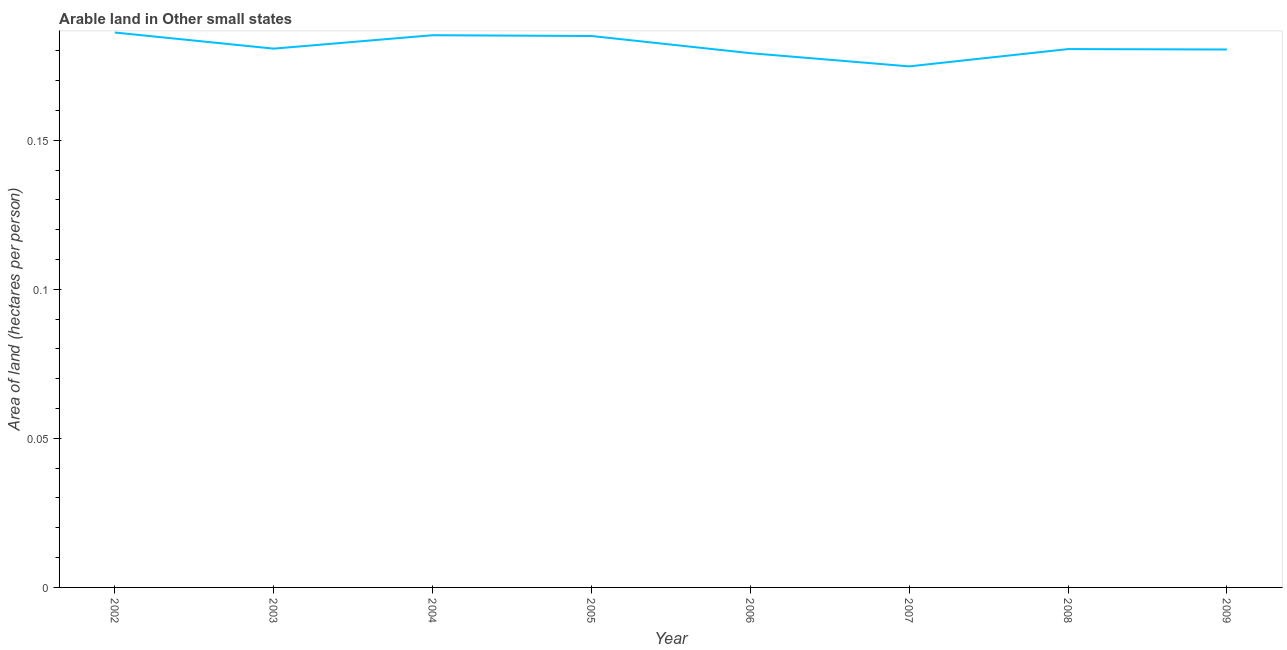What is the area of arable land in 2007?
Offer a terse response. 0.17. Across all years, what is the maximum area of arable land?
Ensure brevity in your answer.  0.19. Across all years, what is the minimum area of arable land?
Ensure brevity in your answer.  0.17. In which year was the area of arable land maximum?
Ensure brevity in your answer.  2002. What is the sum of the area of arable land?
Your answer should be very brief. 1.45. What is the difference between the area of arable land in 2003 and 2006?
Provide a succinct answer. 0. What is the average area of arable land per year?
Your response must be concise. 0.18. What is the median area of arable land?
Provide a succinct answer. 0.18. Do a majority of the years between 2005 and 2007 (inclusive) have area of arable land greater than 0.02 hectares per person?
Your answer should be compact. Yes. What is the ratio of the area of arable land in 2007 to that in 2009?
Offer a terse response. 0.97. Is the difference between the area of arable land in 2002 and 2004 greater than the difference between any two years?
Your answer should be compact. No. What is the difference between the highest and the second highest area of arable land?
Provide a short and direct response. 0. What is the difference between the highest and the lowest area of arable land?
Ensure brevity in your answer.  0.01. In how many years, is the area of arable land greater than the average area of arable land taken over all years?
Offer a very short reply. 3. Does the area of arable land monotonically increase over the years?
Your answer should be very brief. No. How many lines are there?
Offer a very short reply. 1. How many years are there in the graph?
Give a very brief answer. 8. What is the difference between two consecutive major ticks on the Y-axis?
Give a very brief answer. 0.05. Does the graph contain any zero values?
Give a very brief answer. No. Does the graph contain grids?
Provide a succinct answer. No. What is the title of the graph?
Offer a terse response. Arable land in Other small states. What is the label or title of the X-axis?
Ensure brevity in your answer.  Year. What is the label or title of the Y-axis?
Keep it short and to the point. Area of land (hectares per person). What is the Area of land (hectares per person) of 2002?
Your answer should be very brief. 0.19. What is the Area of land (hectares per person) in 2003?
Your response must be concise. 0.18. What is the Area of land (hectares per person) of 2004?
Offer a very short reply. 0.19. What is the Area of land (hectares per person) in 2005?
Offer a terse response. 0.18. What is the Area of land (hectares per person) of 2006?
Your answer should be very brief. 0.18. What is the Area of land (hectares per person) of 2007?
Give a very brief answer. 0.17. What is the Area of land (hectares per person) in 2008?
Keep it short and to the point. 0.18. What is the Area of land (hectares per person) in 2009?
Give a very brief answer. 0.18. What is the difference between the Area of land (hectares per person) in 2002 and 2003?
Provide a short and direct response. 0.01. What is the difference between the Area of land (hectares per person) in 2002 and 2004?
Your answer should be very brief. 0. What is the difference between the Area of land (hectares per person) in 2002 and 2005?
Offer a terse response. 0. What is the difference between the Area of land (hectares per person) in 2002 and 2006?
Your answer should be very brief. 0.01. What is the difference between the Area of land (hectares per person) in 2002 and 2007?
Offer a terse response. 0.01. What is the difference between the Area of land (hectares per person) in 2002 and 2008?
Your answer should be very brief. 0.01. What is the difference between the Area of land (hectares per person) in 2002 and 2009?
Offer a terse response. 0.01. What is the difference between the Area of land (hectares per person) in 2003 and 2004?
Your answer should be compact. -0. What is the difference between the Area of land (hectares per person) in 2003 and 2005?
Give a very brief answer. -0. What is the difference between the Area of land (hectares per person) in 2003 and 2006?
Offer a terse response. 0. What is the difference between the Area of land (hectares per person) in 2003 and 2007?
Your answer should be compact. 0.01. What is the difference between the Area of land (hectares per person) in 2003 and 2008?
Provide a succinct answer. 0. What is the difference between the Area of land (hectares per person) in 2003 and 2009?
Your response must be concise. 0. What is the difference between the Area of land (hectares per person) in 2004 and 2005?
Provide a succinct answer. 0. What is the difference between the Area of land (hectares per person) in 2004 and 2006?
Your answer should be very brief. 0.01. What is the difference between the Area of land (hectares per person) in 2004 and 2007?
Provide a short and direct response. 0.01. What is the difference between the Area of land (hectares per person) in 2004 and 2008?
Ensure brevity in your answer.  0. What is the difference between the Area of land (hectares per person) in 2004 and 2009?
Offer a very short reply. 0. What is the difference between the Area of land (hectares per person) in 2005 and 2006?
Provide a short and direct response. 0.01. What is the difference between the Area of land (hectares per person) in 2005 and 2007?
Provide a succinct answer. 0.01. What is the difference between the Area of land (hectares per person) in 2005 and 2008?
Provide a short and direct response. 0. What is the difference between the Area of land (hectares per person) in 2005 and 2009?
Your answer should be compact. 0. What is the difference between the Area of land (hectares per person) in 2006 and 2007?
Offer a very short reply. 0. What is the difference between the Area of land (hectares per person) in 2006 and 2008?
Offer a terse response. -0. What is the difference between the Area of land (hectares per person) in 2006 and 2009?
Give a very brief answer. -0. What is the difference between the Area of land (hectares per person) in 2007 and 2008?
Provide a short and direct response. -0.01. What is the difference between the Area of land (hectares per person) in 2007 and 2009?
Provide a short and direct response. -0.01. What is the difference between the Area of land (hectares per person) in 2008 and 2009?
Your answer should be compact. 0. What is the ratio of the Area of land (hectares per person) in 2002 to that in 2003?
Give a very brief answer. 1.03. What is the ratio of the Area of land (hectares per person) in 2002 to that in 2006?
Provide a short and direct response. 1.04. What is the ratio of the Area of land (hectares per person) in 2002 to that in 2007?
Keep it short and to the point. 1.06. What is the ratio of the Area of land (hectares per person) in 2002 to that in 2008?
Give a very brief answer. 1.03. What is the ratio of the Area of land (hectares per person) in 2002 to that in 2009?
Your response must be concise. 1.03. What is the ratio of the Area of land (hectares per person) in 2003 to that in 2007?
Provide a short and direct response. 1.03. What is the ratio of the Area of land (hectares per person) in 2003 to that in 2009?
Make the answer very short. 1. What is the ratio of the Area of land (hectares per person) in 2004 to that in 2005?
Provide a succinct answer. 1. What is the ratio of the Area of land (hectares per person) in 2004 to that in 2006?
Provide a succinct answer. 1.03. What is the ratio of the Area of land (hectares per person) in 2004 to that in 2007?
Provide a short and direct response. 1.06. What is the ratio of the Area of land (hectares per person) in 2004 to that in 2009?
Provide a succinct answer. 1.03. What is the ratio of the Area of land (hectares per person) in 2005 to that in 2006?
Offer a very short reply. 1.03. What is the ratio of the Area of land (hectares per person) in 2005 to that in 2007?
Your answer should be very brief. 1.06. What is the ratio of the Area of land (hectares per person) in 2005 to that in 2009?
Your answer should be compact. 1.02. What is the ratio of the Area of land (hectares per person) in 2007 to that in 2008?
Provide a succinct answer. 0.97. 